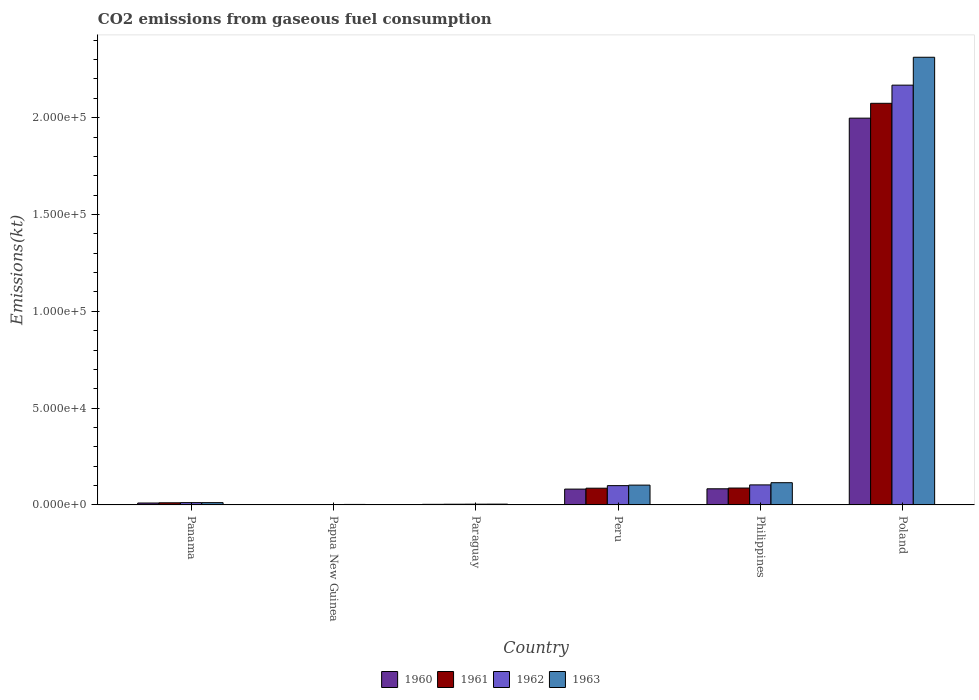How many groups of bars are there?
Your answer should be very brief. 6. What is the amount of CO2 emitted in 1961 in Poland?
Keep it short and to the point. 2.07e+05. Across all countries, what is the maximum amount of CO2 emitted in 1963?
Offer a terse response. 2.31e+05. Across all countries, what is the minimum amount of CO2 emitted in 1962?
Provide a succinct answer. 198.02. In which country was the amount of CO2 emitted in 1962 maximum?
Provide a succinct answer. Poland. In which country was the amount of CO2 emitted in 1962 minimum?
Offer a very short reply. Papua New Guinea. What is the total amount of CO2 emitted in 1961 in the graph?
Your answer should be very brief. 2.26e+05. What is the difference between the amount of CO2 emitted in 1963 in Philippines and that in Poland?
Give a very brief answer. -2.20e+05. What is the difference between the amount of CO2 emitted in 1962 in Papua New Guinea and the amount of CO2 emitted in 1963 in Poland?
Your answer should be very brief. -2.31e+05. What is the average amount of CO2 emitted in 1960 per country?
Offer a very short reply. 3.63e+04. What is the difference between the amount of CO2 emitted of/in 1960 and amount of CO2 emitted of/in 1962 in Papua New Guinea?
Your answer should be very brief. -18.34. What is the ratio of the amount of CO2 emitted in 1962 in Paraguay to that in Peru?
Offer a terse response. 0.04. Is the difference between the amount of CO2 emitted in 1960 in Panama and Papua New Guinea greater than the difference between the amount of CO2 emitted in 1962 in Panama and Papua New Guinea?
Your response must be concise. No. What is the difference between the highest and the second highest amount of CO2 emitted in 1962?
Give a very brief answer. -377.7. What is the difference between the highest and the lowest amount of CO2 emitted in 1963?
Make the answer very short. 2.31e+05. What does the 4th bar from the left in Paraguay represents?
Ensure brevity in your answer.  1963. What does the 2nd bar from the right in Paraguay represents?
Make the answer very short. 1962. How many bars are there?
Offer a very short reply. 24. Are all the bars in the graph horizontal?
Offer a very short reply. No. Are the values on the major ticks of Y-axis written in scientific E-notation?
Your answer should be very brief. Yes. Does the graph contain grids?
Keep it short and to the point. No. How many legend labels are there?
Provide a short and direct response. 4. How are the legend labels stacked?
Give a very brief answer. Horizontal. What is the title of the graph?
Provide a short and direct response. CO2 emissions from gaseous fuel consumption. What is the label or title of the X-axis?
Give a very brief answer. Country. What is the label or title of the Y-axis?
Offer a very short reply. Emissions(kt). What is the Emissions(kt) in 1960 in Panama?
Make the answer very short. 997.42. What is the Emissions(kt) of 1961 in Panama?
Provide a succinct answer. 1103.77. What is the Emissions(kt) in 1962 in Panama?
Keep it short and to the point. 1191.78. What is the Emissions(kt) of 1963 in Panama?
Offer a terse response. 1184.44. What is the Emissions(kt) of 1960 in Papua New Guinea?
Keep it short and to the point. 179.68. What is the Emissions(kt) in 1961 in Papua New Guinea?
Provide a succinct answer. 201.69. What is the Emissions(kt) of 1962 in Papua New Guinea?
Give a very brief answer. 198.02. What is the Emissions(kt) in 1963 in Papua New Guinea?
Provide a short and direct response. 256.69. What is the Emissions(kt) in 1960 in Paraguay?
Make the answer very short. 304.36. What is the Emissions(kt) in 1961 in Paraguay?
Your answer should be very brief. 363.03. What is the Emissions(kt) in 1962 in Paraguay?
Provide a short and direct response. 392.37. What is the Emissions(kt) of 1963 in Paraguay?
Your answer should be compact. 410.7. What is the Emissions(kt) in 1960 in Peru?
Provide a succinct answer. 8173.74. What is the Emissions(kt) in 1961 in Peru?
Your answer should be very brief. 8643.12. What is the Emissions(kt) of 1962 in Peru?
Provide a short and direct response. 9970.57. What is the Emissions(kt) in 1963 in Peru?
Offer a terse response. 1.02e+04. What is the Emissions(kt) in 1960 in Philippines?
Ensure brevity in your answer.  8335.09. What is the Emissions(kt) in 1961 in Philippines?
Provide a succinct answer. 8723.79. What is the Emissions(kt) of 1962 in Philippines?
Keep it short and to the point. 1.03e+04. What is the Emissions(kt) in 1963 in Philippines?
Offer a very short reply. 1.15e+04. What is the Emissions(kt) of 1960 in Poland?
Ensure brevity in your answer.  2.00e+05. What is the Emissions(kt) of 1961 in Poland?
Your answer should be very brief. 2.07e+05. What is the Emissions(kt) in 1962 in Poland?
Ensure brevity in your answer.  2.17e+05. What is the Emissions(kt) of 1963 in Poland?
Offer a terse response. 2.31e+05. Across all countries, what is the maximum Emissions(kt) in 1960?
Provide a short and direct response. 2.00e+05. Across all countries, what is the maximum Emissions(kt) in 1961?
Provide a short and direct response. 2.07e+05. Across all countries, what is the maximum Emissions(kt) in 1962?
Your response must be concise. 2.17e+05. Across all countries, what is the maximum Emissions(kt) of 1963?
Keep it short and to the point. 2.31e+05. Across all countries, what is the minimum Emissions(kt) of 1960?
Provide a succinct answer. 179.68. Across all countries, what is the minimum Emissions(kt) in 1961?
Ensure brevity in your answer.  201.69. Across all countries, what is the minimum Emissions(kt) of 1962?
Offer a very short reply. 198.02. Across all countries, what is the minimum Emissions(kt) of 1963?
Offer a terse response. 256.69. What is the total Emissions(kt) of 1960 in the graph?
Ensure brevity in your answer.  2.18e+05. What is the total Emissions(kt) of 1961 in the graph?
Keep it short and to the point. 2.26e+05. What is the total Emissions(kt) of 1962 in the graph?
Provide a short and direct response. 2.39e+05. What is the total Emissions(kt) in 1963 in the graph?
Offer a terse response. 2.55e+05. What is the difference between the Emissions(kt) in 1960 in Panama and that in Papua New Guinea?
Ensure brevity in your answer.  817.74. What is the difference between the Emissions(kt) in 1961 in Panama and that in Papua New Guinea?
Your answer should be compact. 902.08. What is the difference between the Emissions(kt) in 1962 in Panama and that in Papua New Guinea?
Provide a succinct answer. 993.76. What is the difference between the Emissions(kt) in 1963 in Panama and that in Papua New Guinea?
Provide a succinct answer. 927.75. What is the difference between the Emissions(kt) in 1960 in Panama and that in Paraguay?
Your answer should be very brief. 693.06. What is the difference between the Emissions(kt) of 1961 in Panama and that in Paraguay?
Your answer should be compact. 740.73. What is the difference between the Emissions(kt) of 1962 in Panama and that in Paraguay?
Your answer should be compact. 799.41. What is the difference between the Emissions(kt) of 1963 in Panama and that in Paraguay?
Give a very brief answer. 773.74. What is the difference between the Emissions(kt) in 1960 in Panama and that in Peru?
Your response must be concise. -7176.32. What is the difference between the Emissions(kt) in 1961 in Panama and that in Peru?
Offer a very short reply. -7539.35. What is the difference between the Emissions(kt) in 1962 in Panama and that in Peru?
Offer a terse response. -8778.8. What is the difference between the Emissions(kt) of 1963 in Panama and that in Peru?
Your answer should be very brief. -9050.16. What is the difference between the Emissions(kt) in 1960 in Panama and that in Philippines?
Offer a terse response. -7337.67. What is the difference between the Emissions(kt) of 1961 in Panama and that in Philippines?
Provide a short and direct response. -7620.03. What is the difference between the Emissions(kt) in 1962 in Panama and that in Philippines?
Your answer should be compact. -9156.5. What is the difference between the Emissions(kt) of 1963 in Panama and that in Philippines?
Make the answer very short. -1.03e+04. What is the difference between the Emissions(kt) in 1960 in Panama and that in Poland?
Provide a short and direct response. -1.99e+05. What is the difference between the Emissions(kt) in 1961 in Panama and that in Poland?
Provide a short and direct response. -2.06e+05. What is the difference between the Emissions(kt) in 1962 in Panama and that in Poland?
Ensure brevity in your answer.  -2.16e+05. What is the difference between the Emissions(kt) of 1963 in Panama and that in Poland?
Your answer should be very brief. -2.30e+05. What is the difference between the Emissions(kt) in 1960 in Papua New Guinea and that in Paraguay?
Provide a succinct answer. -124.68. What is the difference between the Emissions(kt) of 1961 in Papua New Guinea and that in Paraguay?
Offer a terse response. -161.35. What is the difference between the Emissions(kt) in 1962 in Papua New Guinea and that in Paraguay?
Offer a very short reply. -194.35. What is the difference between the Emissions(kt) in 1963 in Papua New Guinea and that in Paraguay?
Give a very brief answer. -154.01. What is the difference between the Emissions(kt) of 1960 in Papua New Guinea and that in Peru?
Your response must be concise. -7994.06. What is the difference between the Emissions(kt) of 1961 in Papua New Guinea and that in Peru?
Provide a succinct answer. -8441.43. What is the difference between the Emissions(kt) of 1962 in Papua New Guinea and that in Peru?
Offer a terse response. -9772.56. What is the difference between the Emissions(kt) of 1963 in Papua New Guinea and that in Peru?
Offer a terse response. -9977.91. What is the difference between the Emissions(kt) in 1960 in Papua New Guinea and that in Philippines?
Make the answer very short. -8155.41. What is the difference between the Emissions(kt) of 1961 in Papua New Guinea and that in Philippines?
Ensure brevity in your answer.  -8522.11. What is the difference between the Emissions(kt) in 1962 in Papua New Guinea and that in Philippines?
Keep it short and to the point. -1.02e+04. What is the difference between the Emissions(kt) in 1963 in Papua New Guinea and that in Philippines?
Give a very brief answer. -1.12e+04. What is the difference between the Emissions(kt) of 1960 in Papua New Guinea and that in Poland?
Your answer should be compact. -2.00e+05. What is the difference between the Emissions(kt) in 1961 in Papua New Guinea and that in Poland?
Make the answer very short. -2.07e+05. What is the difference between the Emissions(kt) in 1962 in Papua New Guinea and that in Poland?
Offer a very short reply. -2.17e+05. What is the difference between the Emissions(kt) in 1963 in Papua New Guinea and that in Poland?
Give a very brief answer. -2.31e+05. What is the difference between the Emissions(kt) of 1960 in Paraguay and that in Peru?
Offer a terse response. -7869.38. What is the difference between the Emissions(kt) in 1961 in Paraguay and that in Peru?
Offer a terse response. -8280.09. What is the difference between the Emissions(kt) in 1962 in Paraguay and that in Peru?
Give a very brief answer. -9578.2. What is the difference between the Emissions(kt) of 1963 in Paraguay and that in Peru?
Your answer should be compact. -9823.89. What is the difference between the Emissions(kt) of 1960 in Paraguay and that in Philippines?
Give a very brief answer. -8030.73. What is the difference between the Emissions(kt) of 1961 in Paraguay and that in Philippines?
Provide a short and direct response. -8360.76. What is the difference between the Emissions(kt) of 1962 in Paraguay and that in Philippines?
Keep it short and to the point. -9955.91. What is the difference between the Emissions(kt) of 1963 in Paraguay and that in Philippines?
Ensure brevity in your answer.  -1.11e+04. What is the difference between the Emissions(kt) in 1960 in Paraguay and that in Poland?
Give a very brief answer. -1.99e+05. What is the difference between the Emissions(kt) in 1961 in Paraguay and that in Poland?
Your answer should be compact. -2.07e+05. What is the difference between the Emissions(kt) of 1962 in Paraguay and that in Poland?
Your answer should be compact. -2.16e+05. What is the difference between the Emissions(kt) of 1963 in Paraguay and that in Poland?
Keep it short and to the point. -2.31e+05. What is the difference between the Emissions(kt) in 1960 in Peru and that in Philippines?
Provide a short and direct response. -161.35. What is the difference between the Emissions(kt) in 1961 in Peru and that in Philippines?
Provide a short and direct response. -80.67. What is the difference between the Emissions(kt) of 1962 in Peru and that in Philippines?
Your answer should be very brief. -377.7. What is the difference between the Emissions(kt) of 1963 in Peru and that in Philippines?
Make the answer very short. -1250.45. What is the difference between the Emissions(kt) of 1960 in Peru and that in Poland?
Offer a terse response. -1.92e+05. What is the difference between the Emissions(kt) in 1961 in Peru and that in Poland?
Give a very brief answer. -1.99e+05. What is the difference between the Emissions(kt) in 1962 in Peru and that in Poland?
Provide a short and direct response. -2.07e+05. What is the difference between the Emissions(kt) of 1963 in Peru and that in Poland?
Offer a very short reply. -2.21e+05. What is the difference between the Emissions(kt) in 1960 in Philippines and that in Poland?
Make the answer very short. -1.91e+05. What is the difference between the Emissions(kt) in 1961 in Philippines and that in Poland?
Make the answer very short. -1.99e+05. What is the difference between the Emissions(kt) of 1962 in Philippines and that in Poland?
Your response must be concise. -2.06e+05. What is the difference between the Emissions(kt) of 1963 in Philippines and that in Poland?
Provide a succinct answer. -2.20e+05. What is the difference between the Emissions(kt) of 1960 in Panama and the Emissions(kt) of 1961 in Papua New Guinea?
Your response must be concise. 795.74. What is the difference between the Emissions(kt) of 1960 in Panama and the Emissions(kt) of 1962 in Papua New Guinea?
Provide a succinct answer. 799.41. What is the difference between the Emissions(kt) in 1960 in Panama and the Emissions(kt) in 1963 in Papua New Guinea?
Provide a short and direct response. 740.73. What is the difference between the Emissions(kt) in 1961 in Panama and the Emissions(kt) in 1962 in Papua New Guinea?
Your answer should be compact. 905.75. What is the difference between the Emissions(kt) in 1961 in Panama and the Emissions(kt) in 1963 in Papua New Guinea?
Your response must be concise. 847.08. What is the difference between the Emissions(kt) of 1962 in Panama and the Emissions(kt) of 1963 in Papua New Guinea?
Make the answer very short. 935.09. What is the difference between the Emissions(kt) of 1960 in Panama and the Emissions(kt) of 1961 in Paraguay?
Keep it short and to the point. 634.39. What is the difference between the Emissions(kt) in 1960 in Panama and the Emissions(kt) in 1962 in Paraguay?
Your answer should be very brief. 605.05. What is the difference between the Emissions(kt) in 1960 in Panama and the Emissions(kt) in 1963 in Paraguay?
Make the answer very short. 586.72. What is the difference between the Emissions(kt) of 1961 in Panama and the Emissions(kt) of 1962 in Paraguay?
Offer a very short reply. 711.4. What is the difference between the Emissions(kt) of 1961 in Panama and the Emissions(kt) of 1963 in Paraguay?
Offer a very short reply. 693.06. What is the difference between the Emissions(kt) of 1962 in Panama and the Emissions(kt) of 1963 in Paraguay?
Provide a succinct answer. 781.07. What is the difference between the Emissions(kt) of 1960 in Panama and the Emissions(kt) of 1961 in Peru?
Your answer should be compact. -7645.69. What is the difference between the Emissions(kt) in 1960 in Panama and the Emissions(kt) in 1962 in Peru?
Keep it short and to the point. -8973.15. What is the difference between the Emissions(kt) in 1960 in Panama and the Emissions(kt) in 1963 in Peru?
Keep it short and to the point. -9237.17. What is the difference between the Emissions(kt) of 1961 in Panama and the Emissions(kt) of 1962 in Peru?
Give a very brief answer. -8866.81. What is the difference between the Emissions(kt) of 1961 in Panama and the Emissions(kt) of 1963 in Peru?
Your answer should be compact. -9130.83. What is the difference between the Emissions(kt) in 1962 in Panama and the Emissions(kt) in 1963 in Peru?
Your answer should be very brief. -9042.82. What is the difference between the Emissions(kt) of 1960 in Panama and the Emissions(kt) of 1961 in Philippines?
Make the answer very short. -7726.37. What is the difference between the Emissions(kt) in 1960 in Panama and the Emissions(kt) in 1962 in Philippines?
Make the answer very short. -9350.85. What is the difference between the Emissions(kt) of 1960 in Panama and the Emissions(kt) of 1963 in Philippines?
Offer a very short reply. -1.05e+04. What is the difference between the Emissions(kt) in 1961 in Panama and the Emissions(kt) in 1962 in Philippines?
Ensure brevity in your answer.  -9244.51. What is the difference between the Emissions(kt) of 1961 in Panama and the Emissions(kt) of 1963 in Philippines?
Provide a short and direct response. -1.04e+04. What is the difference between the Emissions(kt) of 1962 in Panama and the Emissions(kt) of 1963 in Philippines?
Keep it short and to the point. -1.03e+04. What is the difference between the Emissions(kt) of 1960 in Panama and the Emissions(kt) of 1961 in Poland?
Give a very brief answer. -2.06e+05. What is the difference between the Emissions(kt) in 1960 in Panama and the Emissions(kt) in 1962 in Poland?
Offer a very short reply. -2.16e+05. What is the difference between the Emissions(kt) in 1960 in Panama and the Emissions(kt) in 1963 in Poland?
Offer a very short reply. -2.30e+05. What is the difference between the Emissions(kt) of 1961 in Panama and the Emissions(kt) of 1962 in Poland?
Your answer should be compact. -2.16e+05. What is the difference between the Emissions(kt) of 1961 in Panama and the Emissions(kt) of 1963 in Poland?
Make the answer very short. -2.30e+05. What is the difference between the Emissions(kt) of 1962 in Panama and the Emissions(kt) of 1963 in Poland?
Offer a very short reply. -2.30e+05. What is the difference between the Emissions(kt) of 1960 in Papua New Guinea and the Emissions(kt) of 1961 in Paraguay?
Offer a terse response. -183.35. What is the difference between the Emissions(kt) in 1960 in Papua New Guinea and the Emissions(kt) in 1962 in Paraguay?
Offer a very short reply. -212.69. What is the difference between the Emissions(kt) in 1960 in Papua New Guinea and the Emissions(kt) in 1963 in Paraguay?
Your response must be concise. -231.02. What is the difference between the Emissions(kt) in 1961 in Papua New Guinea and the Emissions(kt) in 1962 in Paraguay?
Offer a very short reply. -190.68. What is the difference between the Emissions(kt) in 1961 in Papua New Guinea and the Emissions(kt) in 1963 in Paraguay?
Your response must be concise. -209.02. What is the difference between the Emissions(kt) of 1962 in Papua New Guinea and the Emissions(kt) of 1963 in Paraguay?
Keep it short and to the point. -212.69. What is the difference between the Emissions(kt) in 1960 in Papua New Guinea and the Emissions(kt) in 1961 in Peru?
Your answer should be very brief. -8463.44. What is the difference between the Emissions(kt) of 1960 in Papua New Guinea and the Emissions(kt) of 1962 in Peru?
Provide a short and direct response. -9790.89. What is the difference between the Emissions(kt) of 1960 in Papua New Guinea and the Emissions(kt) of 1963 in Peru?
Your answer should be compact. -1.01e+04. What is the difference between the Emissions(kt) of 1961 in Papua New Guinea and the Emissions(kt) of 1962 in Peru?
Your response must be concise. -9768.89. What is the difference between the Emissions(kt) of 1961 in Papua New Guinea and the Emissions(kt) of 1963 in Peru?
Your answer should be compact. -1.00e+04. What is the difference between the Emissions(kt) of 1962 in Papua New Guinea and the Emissions(kt) of 1963 in Peru?
Provide a succinct answer. -1.00e+04. What is the difference between the Emissions(kt) in 1960 in Papua New Guinea and the Emissions(kt) in 1961 in Philippines?
Your response must be concise. -8544.11. What is the difference between the Emissions(kt) in 1960 in Papua New Guinea and the Emissions(kt) in 1962 in Philippines?
Give a very brief answer. -1.02e+04. What is the difference between the Emissions(kt) of 1960 in Papua New Guinea and the Emissions(kt) of 1963 in Philippines?
Provide a succinct answer. -1.13e+04. What is the difference between the Emissions(kt) of 1961 in Papua New Guinea and the Emissions(kt) of 1962 in Philippines?
Make the answer very short. -1.01e+04. What is the difference between the Emissions(kt) in 1961 in Papua New Guinea and the Emissions(kt) in 1963 in Philippines?
Give a very brief answer. -1.13e+04. What is the difference between the Emissions(kt) of 1962 in Papua New Guinea and the Emissions(kt) of 1963 in Philippines?
Provide a short and direct response. -1.13e+04. What is the difference between the Emissions(kt) of 1960 in Papua New Guinea and the Emissions(kt) of 1961 in Poland?
Your answer should be very brief. -2.07e+05. What is the difference between the Emissions(kt) in 1960 in Papua New Guinea and the Emissions(kt) in 1962 in Poland?
Make the answer very short. -2.17e+05. What is the difference between the Emissions(kt) of 1960 in Papua New Guinea and the Emissions(kt) of 1963 in Poland?
Give a very brief answer. -2.31e+05. What is the difference between the Emissions(kt) in 1961 in Papua New Guinea and the Emissions(kt) in 1962 in Poland?
Provide a short and direct response. -2.17e+05. What is the difference between the Emissions(kt) in 1961 in Papua New Guinea and the Emissions(kt) in 1963 in Poland?
Offer a terse response. -2.31e+05. What is the difference between the Emissions(kt) of 1962 in Papua New Guinea and the Emissions(kt) of 1963 in Poland?
Your answer should be very brief. -2.31e+05. What is the difference between the Emissions(kt) in 1960 in Paraguay and the Emissions(kt) in 1961 in Peru?
Give a very brief answer. -8338.76. What is the difference between the Emissions(kt) in 1960 in Paraguay and the Emissions(kt) in 1962 in Peru?
Offer a terse response. -9666.21. What is the difference between the Emissions(kt) of 1960 in Paraguay and the Emissions(kt) of 1963 in Peru?
Make the answer very short. -9930.24. What is the difference between the Emissions(kt) in 1961 in Paraguay and the Emissions(kt) in 1962 in Peru?
Offer a very short reply. -9607.54. What is the difference between the Emissions(kt) of 1961 in Paraguay and the Emissions(kt) of 1963 in Peru?
Provide a succinct answer. -9871.56. What is the difference between the Emissions(kt) of 1962 in Paraguay and the Emissions(kt) of 1963 in Peru?
Offer a very short reply. -9842.23. What is the difference between the Emissions(kt) in 1960 in Paraguay and the Emissions(kt) in 1961 in Philippines?
Offer a very short reply. -8419.43. What is the difference between the Emissions(kt) of 1960 in Paraguay and the Emissions(kt) of 1962 in Philippines?
Offer a terse response. -1.00e+04. What is the difference between the Emissions(kt) of 1960 in Paraguay and the Emissions(kt) of 1963 in Philippines?
Keep it short and to the point. -1.12e+04. What is the difference between the Emissions(kt) in 1961 in Paraguay and the Emissions(kt) in 1962 in Philippines?
Your response must be concise. -9985.24. What is the difference between the Emissions(kt) of 1961 in Paraguay and the Emissions(kt) of 1963 in Philippines?
Make the answer very short. -1.11e+04. What is the difference between the Emissions(kt) in 1962 in Paraguay and the Emissions(kt) in 1963 in Philippines?
Offer a terse response. -1.11e+04. What is the difference between the Emissions(kt) of 1960 in Paraguay and the Emissions(kt) of 1961 in Poland?
Provide a succinct answer. -2.07e+05. What is the difference between the Emissions(kt) of 1960 in Paraguay and the Emissions(kt) of 1962 in Poland?
Provide a succinct answer. -2.17e+05. What is the difference between the Emissions(kt) in 1960 in Paraguay and the Emissions(kt) in 1963 in Poland?
Make the answer very short. -2.31e+05. What is the difference between the Emissions(kt) of 1961 in Paraguay and the Emissions(kt) of 1962 in Poland?
Ensure brevity in your answer.  -2.16e+05. What is the difference between the Emissions(kt) in 1961 in Paraguay and the Emissions(kt) in 1963 in Poland?
Offer a very short reply. -2.31e+05. What is the difference between the Emissions(kt) of 1962 in Paraguay and the Emissions(kt) of 1963 in Poland?
Offer a terse response. -2.31e+05. What is the difference between the Emissions(kt) in 1960 in Peru and the Emissions(kt) in 1961 in Philippines?
Your response must be concise. -550.05. What is the difference between the Emissions(kt) in 1960 in Peru and the Emissions(kt) in 1962 in Philippines?
Provide a short and direct response. -2174.53. What is the difference between the Emissions(kt) of 1960 in Peru and the Emissions(kt) of 1963 in Philippines?
Your answer should be very brief. -3311.3. What is the difference between the Emissions(kt) of 1961 in Peru and the Emissions(kt) of 1962 in Philippines?
Ensure brevity in your answer.  -1705.15. What is the difference between the Emissions(kt) in 1961 in Peru and the Emissions(kt) in 1963 in Philippines?
Ensure brevity in your answer.  -2841.93. What is the difference between the Emissions(kt) of 1962 in Peru and the Emissions(kt) of 1963 in Philippines?
Offer a terse response. -1514.47. What is the difference between the Emissions(kt) of 1960 in Peru and the Emissions(kt) of 1961 in Poland?
Make the answer very short. -1.99e+05. What is the difference between the Emissions(kt) of 1960 in Peru and the Emissions(kt) of 1962 in Poland?
Keep it short and to the point. -2.09e+05. What is the difference between the Emissions(kt) in 1960 in Peru and the Emissions(kt) in 1963 in Poland?
Give a very brief answer. -2.23e+05. What is the difference between the Emissions(kt) in 1961 in Peru and the Emissions(kt) in 1962 in Poland?
Your answer should be very brief. -2.08e+05. What is the difference between the Emissions(kt) in 1961 in Peru and the Emissions(kt) in 1963 in Poland?
Your response must be concise. -2.23e+05. What is the difference between the Emissions(kt) in 1962 in Peru and the Emissions(kt) in 1963 in Poland?
Offer a terse response. -2.21e+05. What is the difference between the Emissions(kt) of 1960 in Philippines and the Emissions(kt) of 1961 in Poland?
Provide a succinct answer. -1.99e+05. What is the difference between the Emissions(kt) in 1960 in Philippines and the Emissions(kt) in 1962 in Poland?
Keep it short and to the point. -2.08e+05. What is the difference between the Emissions(kt) of 1960 in Philippines and the Emissions(kt) of 1963 in Poland?
Give a very brief answer. -2.23e+05. What is the difference between the Emissions(kt) in 1961 in Philippines and the Emissions(kt) in 1962 in Poland?
Offer a very short reply. -2.08e+05. What is the difference between the Emissions(kt) in 1961 in Philippines and the Emissions(kt) in 1963 in Poland?
Make the answer very short. -2.22e+05. What is the difference between the Emissions(kt) of 1962 in Philippines and the Emissions(kt) of 1963 in Poland?
Ensure brevity in your answer.  -2.21e+05. What is the average Emissions(kt) of 1960 per country?
Provide a succinct answer. 3.63e+04. What is the average Emissions(kt) of 1961 per country?
Ensure brevity in your answer.  3.77e+04. What is the average Emissions(kt) of 1962 per country?
Provide a succinct answer. 3.98e+04. What is the average Emissions(kt) of 1963 per country?
Keep it short and to the point. 4.25e+04. What is the difference between the Emissions(kt) of 1960 and Emissions(kt) of 1961 in Panama?
Provide a short and direct response. -106.34. What is the difference between the Emissions(kt) of 1960 and Emissions(kt) of 1962 in Panama?
Provide a succinct answer. -194.35. What is the difference between the Emissions(kt) in 1960 and Emissions(kt) in 1963 in Panama?
Provide a succinct answer. -187.02. What is the difference between the Emissions(kt) in 1961 and Emissions(kt) in 1962 in Panama?
Offer a terse response. -88.01. What is the difference between the Emissions(kt) in 1961 and Emissions(kt) in 1963 in Panama?
Your answer should be compact. -80.67. What is the difference between the Emissions(kt) of 1962 and Emissions(kt) of 1963 in Panama?
Provide a short and direct response. 7.33. What is the difference between the Emissions(kt) in 1960 and Emissions(kt) in 1961 in Papua New Guinea?
Your response must be concise. -22. What is the difference between the Emissions(kt) of 1960 and Emissions(kt) of 1962 in Papua New Guinea?
Your answer should be compact. -18.34. What is the difference between the Emissions(kt) in 1960 and Emissions(kt) in 1963 in Papua New Guinea?
Give a very brief answer. -77.01. What is the difference between the Emissions(kt) in 1961 and Emissions(kt) in 1962 in Papua New Guinea?
Ensure brevity in your answer.  3.67. What is the difference between the Emissions(kt) of 1961 and Emissions(kt) of 1963 in Papua New Guinea?
Your response must be concise. -55.01. What is the difference between the Emissions(kt) of 1962 and Emissions(kt) of 1963 in Papua New Guinea?
Offer a terse response. -58.67. What is the difference between the Emissions(kt) of 1960 and Emissions(kt) of 1961 in Paraguay?
Provide a short and direct response. -58.67. What is the difference between the Emissions(kt) of 1960 and Emissions(kt) of 1962 in Paraguay?
Make the answer very short. -88.01. What is the difference between the Emissions(kt) in 1960 and Emissions(kt) in 1963 in Paraguay?
Your response must be concise. -106.34. What is the difference between the Emissions(kt) in 1961 and Emissions(kt) in 1962 in Paraguay?
Provide a succinct answer. -29.34. What is the difference between the Emissions(kt) in 1961 and Emissions(kt) in 1963 in Paraguay?
Provide a short and direct response. -47.67. What is the difference between the Emissions(kt) in 1962 and Emissions(kt) in 1963 in Paraguay?
Your answer should be compact. -18.34. What is the difference between the Emissions(kt) in 1960 and Emissions(kt) in 1961 in Peru?
Make the answer very short. -469.38. What is the difference between the Emissions(kt) in 1960 and Emissions(kt) in 1962 in Peru?
Ensure brevity in your answer.  -1796.83. What is the difference between the Emissions(kt) in 1960 and Emissions(kt) in 1963 in Peru?
Your answer should be very brief. -2060.85. What is the difference between the Emissions(kt) in 1961 and Emissions(kt) in 1962 in Peru?
Provide a succinct answer. -1327.45. What is the difference between the Emissions(kt) of 1961 and Emissions(kt) of 1963 in Peru?
Ensure brevity in your answer.  -1591.48. What is the difference between the Emissions(kt) of 1962 and Emissions(kt) of 1963 in Peru?
Your response must be concise. -264.02. What is the difference between the Emissions(kt) of 1960 and Emissions(kt) of 1961 in Philippines?
Offer a very short reply. -388.7. What is the difference between the Emissions(kt) in 1960 and Emissions(kt) in 1962 in Philippines?
Keep it short and to the point. -2013.18. What is the difference between the Emissions(kt) in 1960 and Emissions(kt) in 1963 in Philippines?
Your response must be concise. -3149.95. What is the difference between the Emissions(kt) in 1961 and Emissions(kt) in 1962 in Philippines?
Ensure brevity in your answer.  -1624.48. What is the difference between the Emissions(kt) in 1961 and Emissions(kt) in 1963 in Philippines?
Offer a terse response. -2761.25. What is the difference between the Emissions(kt) of 1962 and Emissions(kt) of 1963 in Philippines?
Your answer should be compact. -1136.77. What is the difference between the Emissions(kt) of 1960 and Emissions(kt) of 1961 in Poland?
Offer a very short reply. -7667.7. What is the difference between the Emissions(kt) of 1960 and Emissions(kt) of 1962 in Poland?
Keep it short and to the point. -1.70e+04. What is the difference between the Emissions(kt) in 1960 and Emissions(kt) in 1963 in Poland?
Your response must be concise. -3.15e+04. What is the difference between the Emissions(kt) in 1961 and Emissions(kt) in 1962 in Poland?
Your answer should be compact. -9380.19. What is the difference between the Emissions(kt) of 1961 and Emissions(kt) of 1963 in Poland?
Your response must be concise. -2.38e+04. What is the difference between the Emissions(kt) of 1962 and Emissions(kt) of 1963 in Poland?
Provide a succinct answer. -1.44e+04. What is the ratio of the Emissions(kt) of 1960 in Panama to that in Papua New Guinea?
Give a very brief answer. 5.55. What is the ratio of the Emissions(kt) of 1961 in Panama to that in Papua New Guinea?
Your answer should be compact. 5.47. What is the ratio of the Emissions(kt) in 1962 in Panama to that in Papua New Guinea?
Keep it short and to the point. 6.02. What is the ratio of the Emissions(kt) in 1963 in Panama to that in Papua New Guinea?
Keep it short and to the point. 4.61. What is the ratio of the Emissions(kt) of 1960 in Panama to that in Paraguay?
Offer a terse response. 3.28. What is the ratio of the Emissions(kt) in 1961 in Panama to that in Paraguay?
Keep it short and to the point. 3.04. What is the ratio of the Emissions(kt) of 1962 in Panama to that in Paraguay?
Your answer should be compact. 3.04. What is the ratio of the Emissions(kt) of 1963 in Panama to that in Paraguay?
Keep it short and to the point. 2.88. What is the ratio of the Emissions(kt) in 1960 in Panama to that in Peru?
Make the answer very short. 0.12. What is the ratio of the Emissions(kt) in 1961 in Panama to that in Peru?
Provide a succinct answer. 0.13. What is the ratio of the Emissions(kt) of 1962 in Panama to that in Peru?
Provide a succinct answer. 0.12. What is the ratio of the Emissions(kt) in 1963 in Panama to that in Peru?
Your answer should be very brief. 0.12. What is the ratio of the Emissions(kt) in 1960 in Panama to that in Philippines?
Keep it short and to the point. 0.12. What is the ratio of the Emissions(kt) in 1961 in Panama to that in Philippines?
Offer a terse response. 0.13. What is the ratio of the Emissions(kt) in 1962 in Panama to that in Philippines?
Provide a short and direct response. 0.12. What is the ratio of the Emissions(kt) of 1963 in Panama to that in Philippines?
Ensure brevity in your answer.  0.1. What is the ratio of the Emissions(kt) of 1960 in Panama to that in Poland?
Your answer should be very brief. 0.01. What is the ratio of the Emissions(kt) in 1961 in Panama to that in Poland?
Give a very brief answer. 0.01. What is the ratio of the Emissions(kt) in 1962 in Panama to that in Poland?
Provide a short and direct response. 0.01. What is the ratio of the Emissions(kt) of 1963 in Panama to that in Poland?
Provide a short and direct response. 0.01. What is the ratio of the Emissions(kt) in 1960 in Papua New Guinea to that in Paraguay?
Keep it short and to the point. 0.59. What is the ratio of the Emissions(kt) in 1961 in Papua New Guinea to that in Paraguay?
Your answer should be compact. 0.56. What is the ratio of the Emissions(kt) of 1962 in Papua New Guinea to that in Paraguay?
Your answer should be very brief. 0.5. What is the ratio of the Emissions(kt) in 1960 in Papua New Guinea to that in Peru?
Give a very brief answer. 0.02. What is the ratio of the Emissions(kt) of 1961 in Papua New Guinea to that in Peru?
Your response must be concise. 0.02. What is the ratio of the Emissions(kt) of 1962 in Papua New Guinea to that in Peru?
Offer a very short reply. 0.02. What is the ratio of the Emissions(kt) in 1963 in Papua New Guinea to that in Peru?
Ensure brevity in your answer.  0.03. What is the ratio of the Emissions(kt) in 1960 in Papua New Guinea to that in Philippines?
Offer a very short reply. 0.02. What is the ratio of the Emissions(kt) in 1961 in Papua New Guinea to that in Philippines?
Your response must be concise. 0.02. What is the ratio of the Emissions(kt) in 1962 in Papua New Guinea to that in Philippines?
Ensure brevity in your answer.  0.02. What is the ratio of the Emissions(kt) in 1963 in Papua New Guinea to that in Philippines?
Offer a very short reply. 0.02. What is the ratio of the Emissions(kt) in 1960 in Papua New Guinea to that in Poland?
Provide a short and direct response. 0. What is the ratio of the Emissions(kt) of 1961 in Papua New Guinea to that in Poland?
Provide a short and direct response. 0. What is the ratio of the Emissions(kt) in 1962 in Papua New Guinea to that in Poland?
Make the answer very short. 0. What is the ratio of the Emissions(kt) in 1963 in Papua New Guinea to that in Poland?
Offer a terse response. 0. What is the ratio of the Emissions(kt) of 1960 in Paraguay to that in Peru?
Provide a short and direct response. 0.04. What is the ratio of the Emissions(kt) of 1961 in Paraguay to that in Peru?
Ensure brevity in your answer.  0.04. What is the ratio of the Emissions(kt) of 1962 in Paraguay to that in Peru?
Make the answer very short. 0.04. What is the ratio of the Emissions(kt) of 1963 in Paraguay to that in Peru?
Provide a succinct answer. 0.04. What is the ratio of the Emissions(kt) in 1960 in Paraguay to that in Philippines?
Provide a short and direct response. 0.04. What is the ratio of the Emissions(kt) in 1961 in Paraguay to that in Philippines?
Give a very brief answer. 0.04. What is the ratio of the Emissions(kt) of 1962 in Paraguay to that in Philippines?
Provide a succinct answer. 0.04. What is the ratio of the Emissions(kt) of 1963 in Paraguay to that in Philippines?
Ensure brevity in your answer.  0.04. What is the ratio of the Emissions(kt) of 1960 in Paraguay to that in Poland?
Offer a terse response. 0. What is the ratio of the Emissions(kt) in 1961 in Paraguay to that in Poland?
Keep it short and to the point. 0. What is the ratio of the Emissions(kt) in 1962 in Paraguay to that in Poland?
Your answer should be compact. 0. What is the ratio of the Emissions(kt) of 1963 in Paraguay to that in Poland?
Make the answer very short. 0. What is the ratio of the Emissions(kt) in 1960 in Peru to that in Philippines?
Ensure brevity in your answer.  0.98. What is the ratio of the Emissions(kt) of 1962 in Peru to that in Philippines?
Provide a short and direct response. 0.96. What is the ratio of the Emissions(kt) in 1963 in Peru to that in Philippines?
Your answer should be compact. 0.89. What is the ratio of the Emissions(kt) in 1960 in Peru to that in Poland?
Offer a very short reply. 0.04. What is the ratio of the Emissions(kt) in 1961 in Peru to that in Poland?
Your response must be concise. 0.04. What is the ratio of the Emissions(kt) in 1962 in Peru to that in Poland?
Ensure brevity in your answer.  0.05. What is the ratio of the Emissions(kt) of 1963 in Peru to that in Poland?
Offer a very short reply. 0.04. What is the ratio of the Emissions(kt) of 1960 in Philippines to that in Poland?
Provide a succinct answer. 0.04. What is the ratio of the Emissions(kt) of 1961 in Philippines to that in Poland?
Provide a short and direct response. 0.04. What is the ratio of the Emissions(kt) in 1962 in Philippines to that in Poland?
Provide a succinct answer. 0.05. What is the ratio of the Emissions(kt) in 1963 in Philippines to that in Poland?
Make the answer very short. 0.05. What is the difference between the highest and the second highest Emissions(kt) of 1960?
Give a very brief answer. 1.91e+05. What is the difference between the highest and the second highest Emissions(kt) of 1961?
Your answer should be very brief. 1.99e+05. What is the difference between the highest and the second highest Emissions(kt) of 1962?
Provide a short and direct response. 2.06e+05. What is the difference between the highest and the second highest Emissions(kt) of 1963?
Provide a succinct answer. 2.20e+05. What is the difference between the highest and the lowest Emissions(kt) of 1960?
Your answer should be compact. 2.00e+05. What is the difference between the highest and the lowest Emissions(kt) of 1961?
Your answer should be compact. 2.07e+05. What is the difference between the highest and the lowest Emissions(kt) in 1962?
Your response must be concise. 2.17e+05. What is the difference between the highest and the lowest Emissions(kt) of 1963?
Your answer should be very brief. 2.31e+05. 